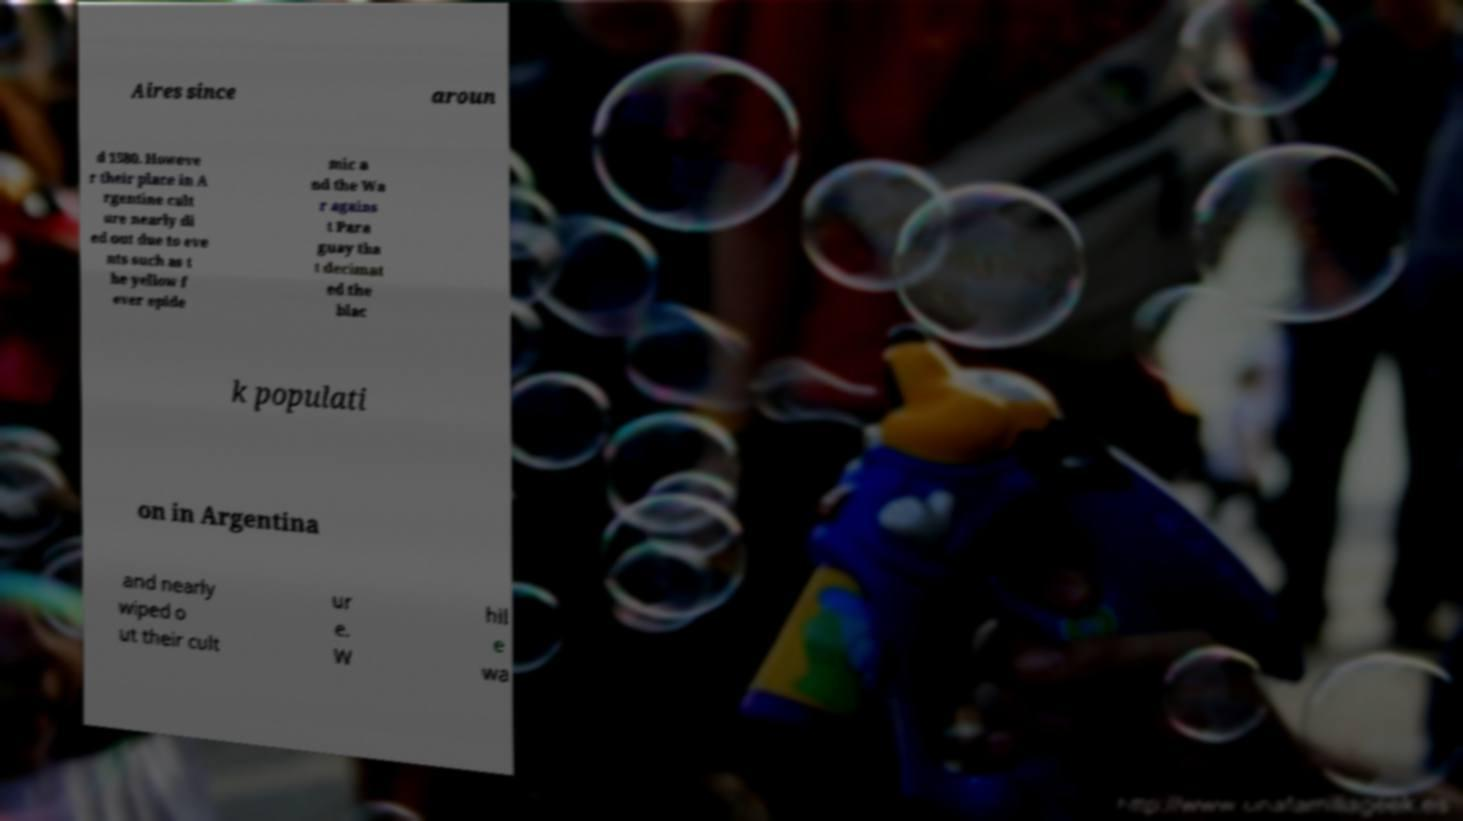I need the written content from this picture converted into text. Can you do that? Aires since aroun d 1580. Howeve r their place in A rgentine cult ure nearly di ed out due to eve nts such as t he yellow f ever epide mic a nd the Wa r agains t Para guay tha t decimat ed the blac k populati on in Argentina and nearly wiped o ut their cult ur e. W hil e wa 